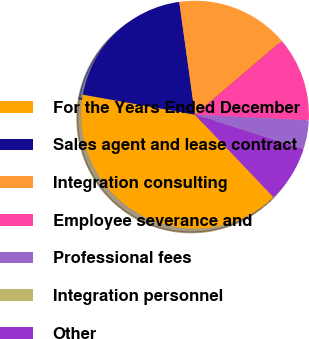Convert chart to OTSL. <chart><loc_0><loc_0><loc_500><loc_500><pie_chart><fcel>For the Years Ended December<fcel>Sales agent and lease contract<fcel>Integration consulting<fcel>Employee severance and<fcel>Professional fees<fcel>Integration personnel<fcel>Other<nl><fcel>39.93%<fcel>19.98%<fcel>16.0%<fcel>12.01%<fcel>4.03%<fcel>0.04%<fcel>8.02%<nl></chart> 